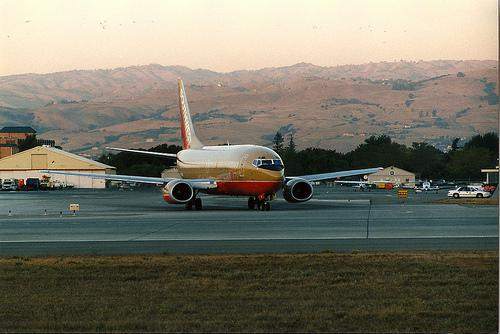Question: what kind of vehicle is nearest?
Choices:
A. An airplane.
B. A scooter.
C. A go cart.
D. A car.
Answer with the letter. Answer: A Question: what color is the top half of the plane?
Choices:
A. White.
B. Blue.
C. Grey.
D. Gold.
Answer with the letter. Answer: D Question: where was the picture taken?
Choices:
A. At an airport.
B. In the stadium.
C. At a party.
D. Behind the house.
Answer with the letter. Answer: A 